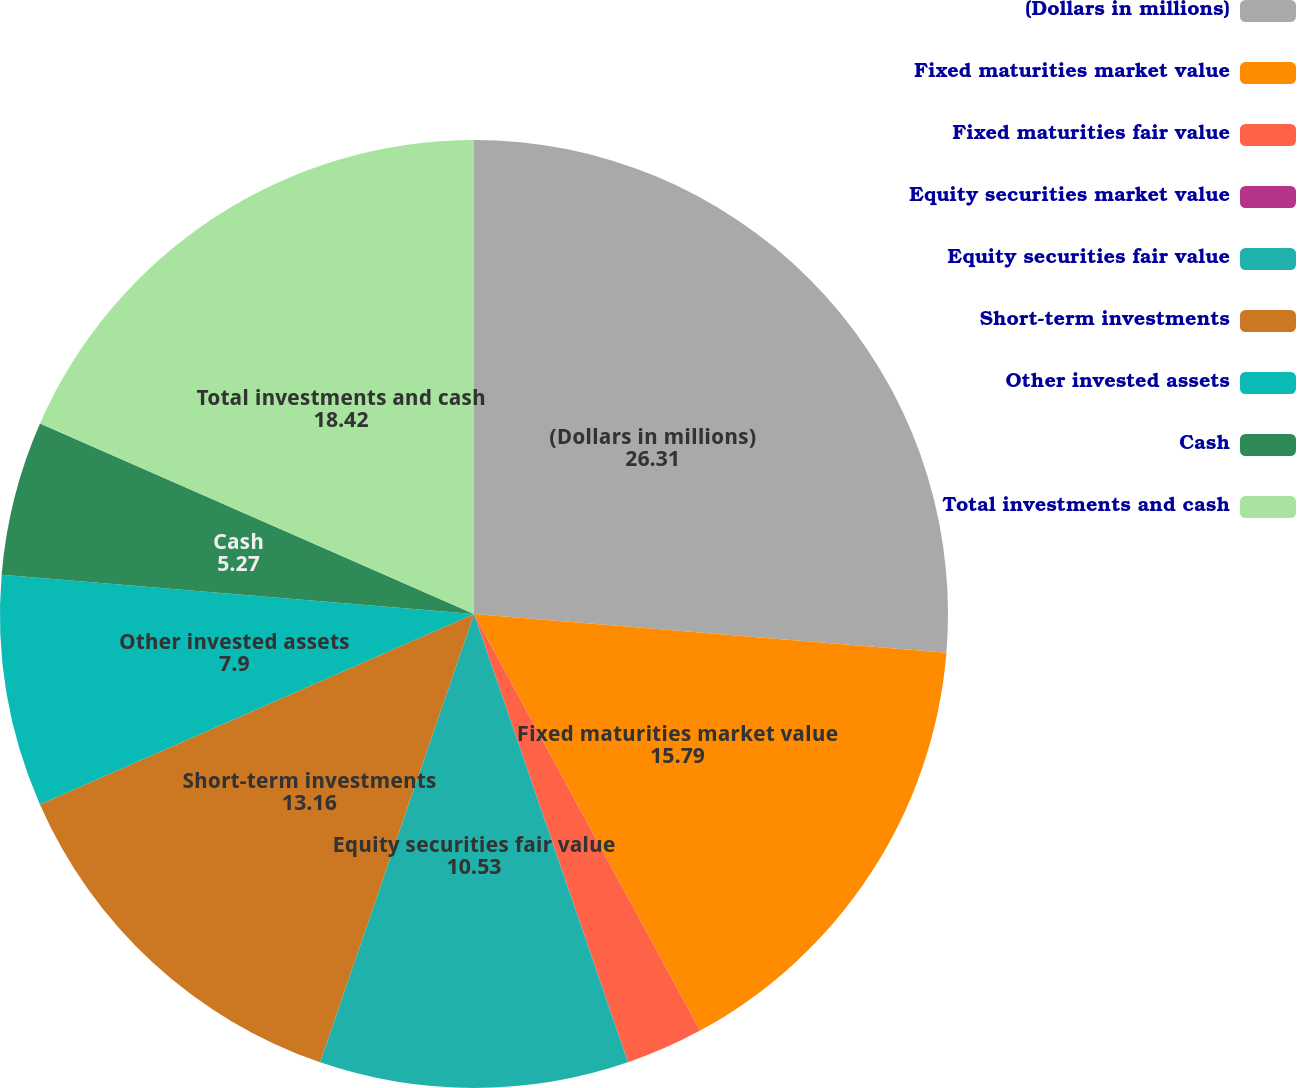Convert chart. <chart><loc_0><loc_0><loc_500><loc_500><pie_chart><fcel>(Dollars in millions)<fcel>Fixed maturities market value<fcel>Fixed maturities fair value<fcel>Equity securities market value<fcel>Equity securities fair value<fcel>Short-term investments<fcel>Other invested assets<fcel>Cash<fcel>Total investments and cash<nl><fcel>26.31%<fcel>15.79%<fcel>2.64%<fcel>0.01%<fcel>10.53%<fcel>13.16%<fcel>7.9%<fcel>5.27%<fcel>18.42%<nl></chart> 